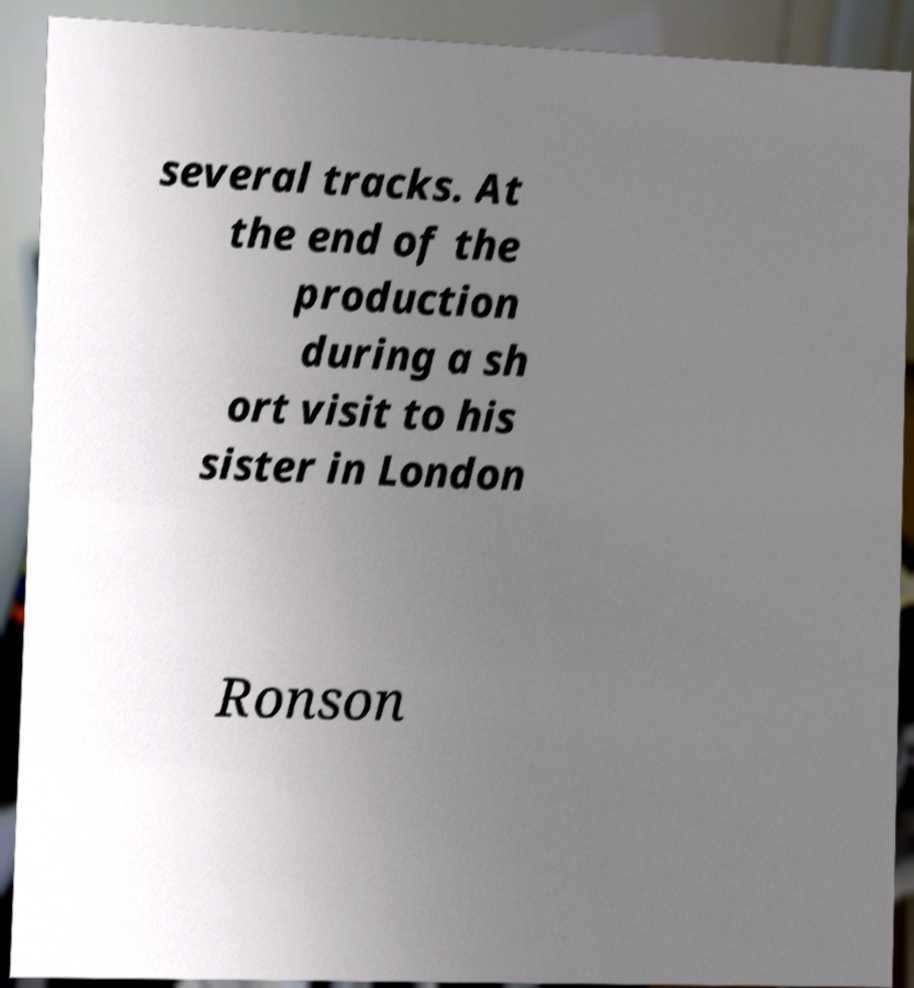Could you extract and type out the text from this image? several tracks. At the end of the production during a sh ort visit to his sister in London Ronson 